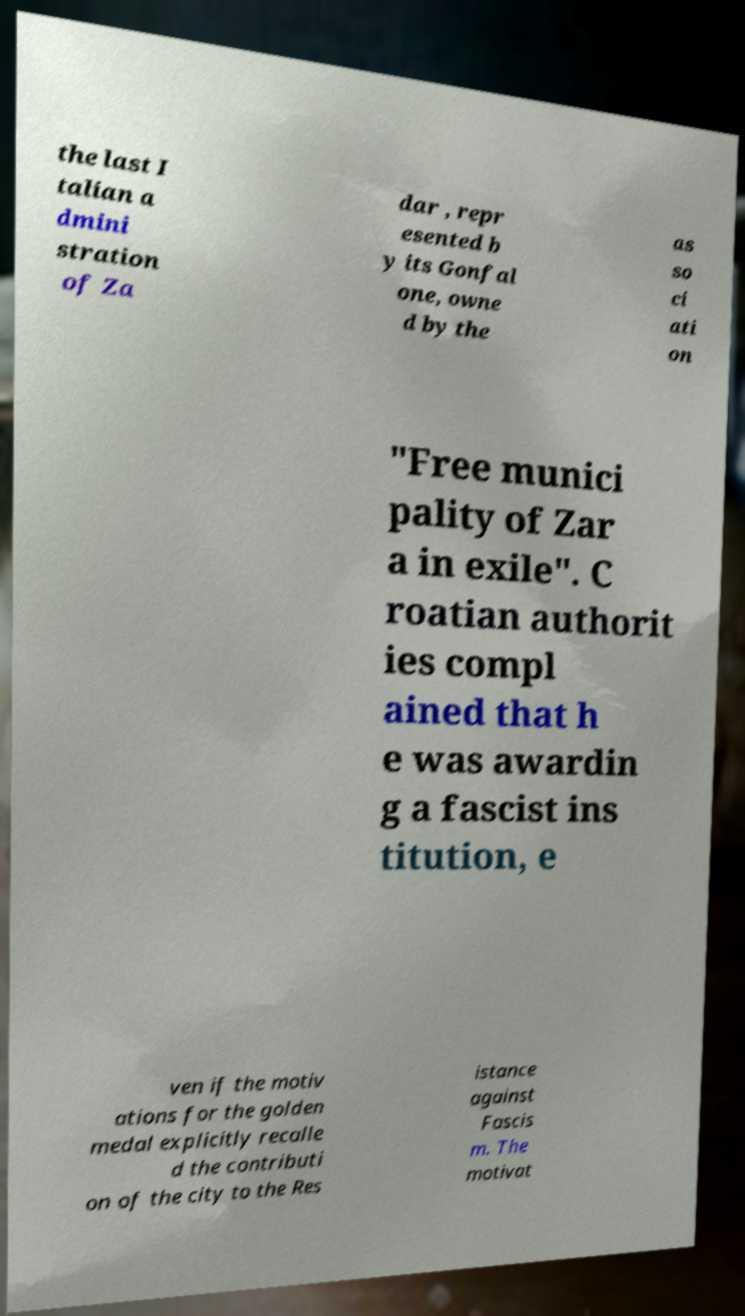Please identify and transcribe the text found in this image. the last I talian a dmini stration of Za dar , repr esented b y its Gonfal one, owne d by the as so ci ati on "Free munici pality of Zar a in exile". C roatian authorit ies compl ained that h e was awardin g a fascist ins titution, e ven if the motiv ations for the golden medal explicitly recalle d the contributi on of the city to the Res istance against Fascis m. The motivat 